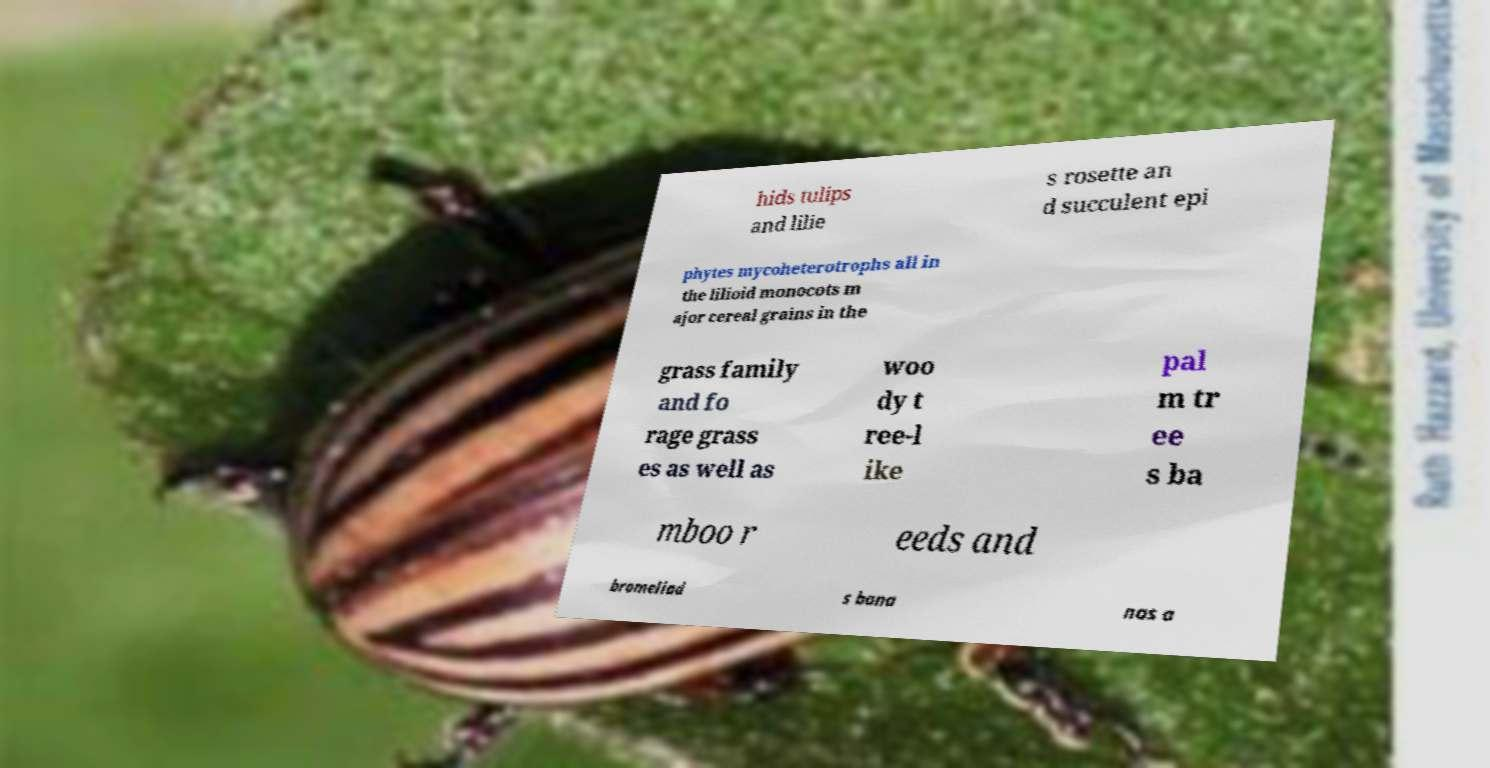There's text embedded in this image that I need extracted. Can you transcribe it verbatim? hids tulips and lilie s rosette an d succulent epi phytes mycoheterotrophs all in the lilioid monocots m ajor cereal grains in the grass family and fo rage grass es as well as woo dy t ree-l ike pal m tr ee s ba mboo r eeds and bromeliad s bana nas a 